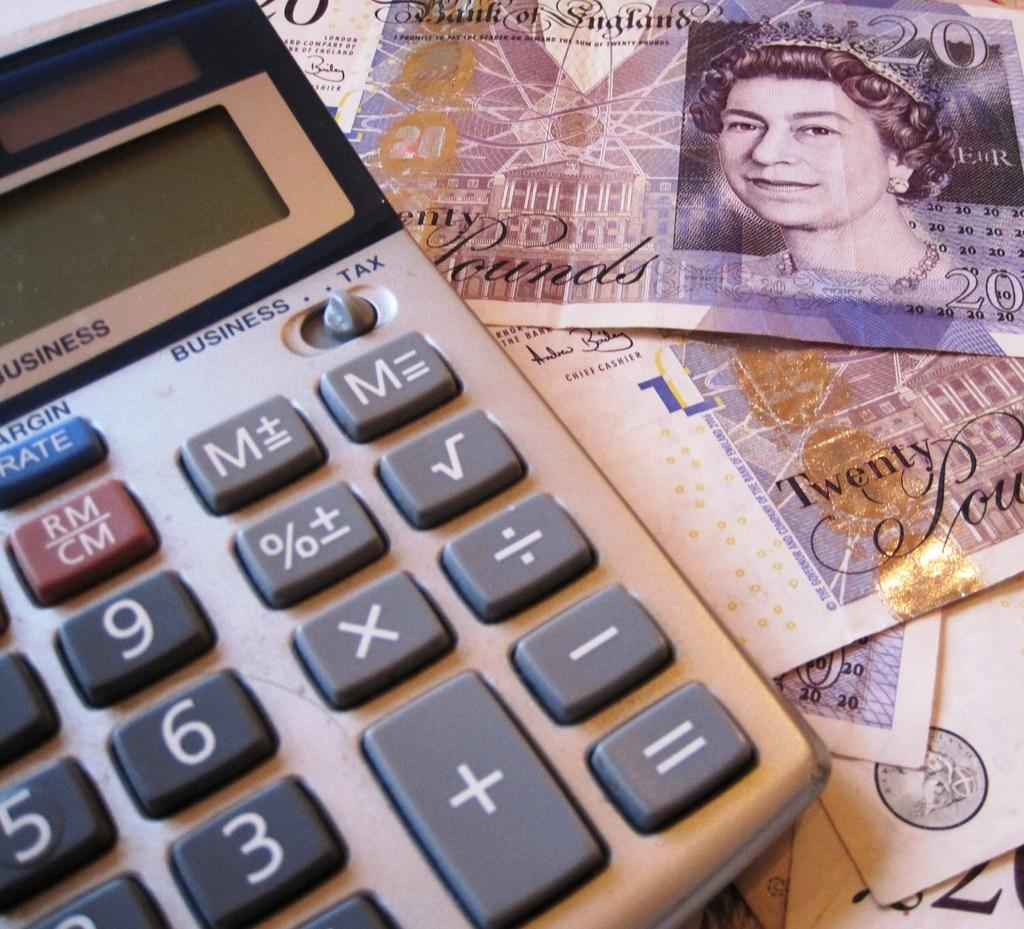<image>
Write a terse but informative summary of the picture. Underneath the calculator was a twenty pound bill. 